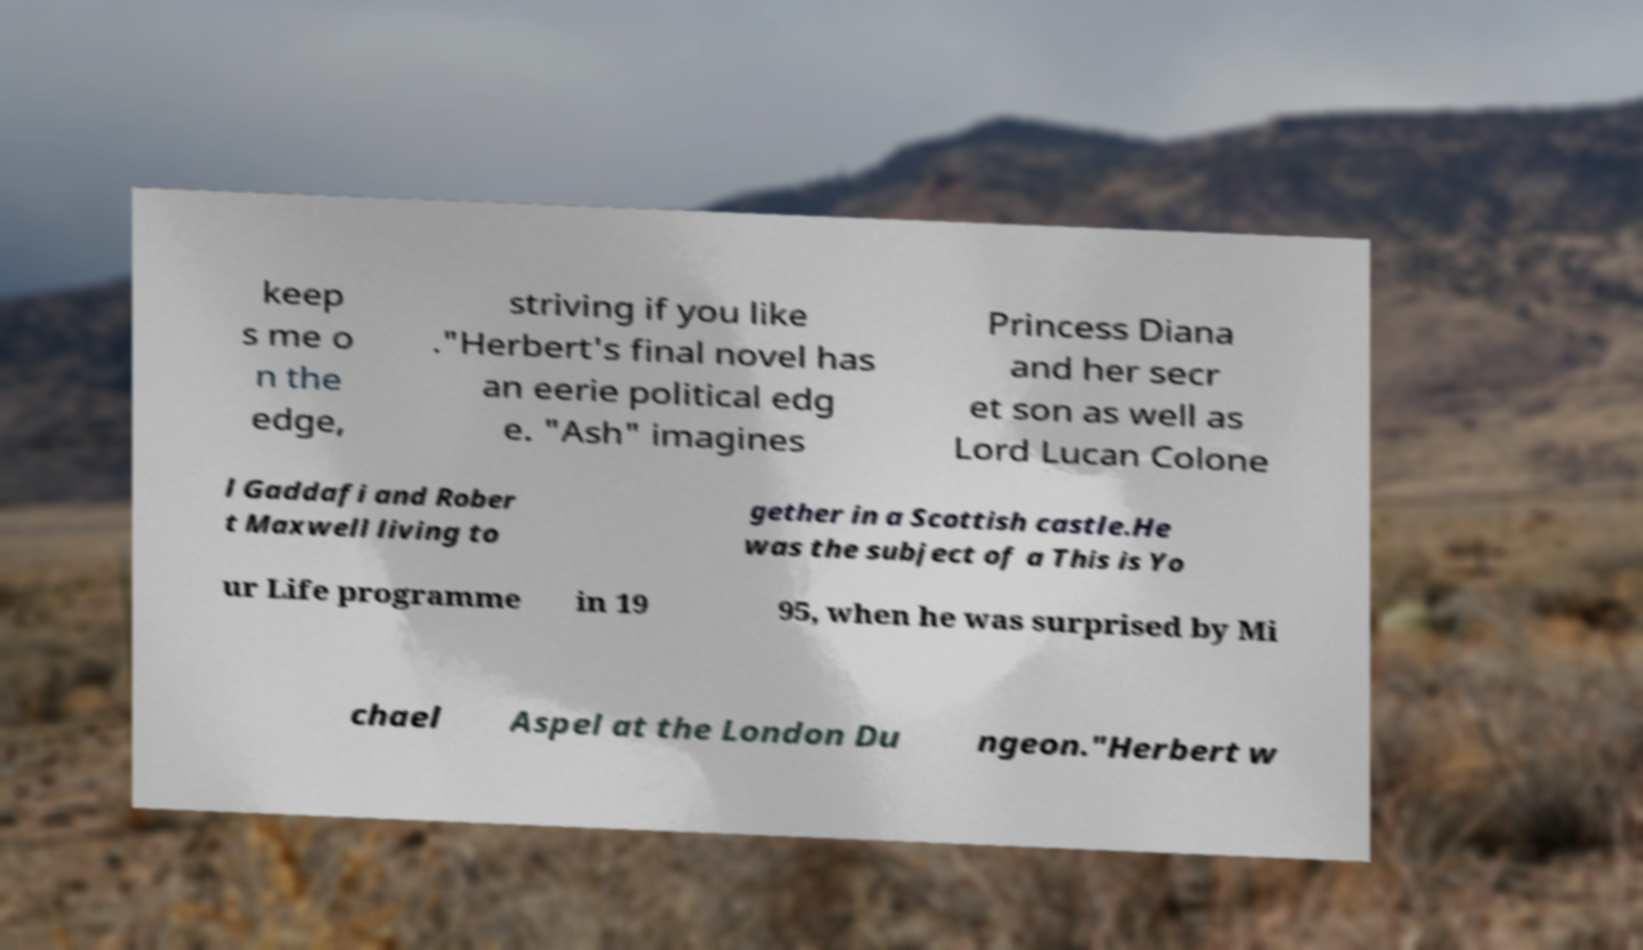For documentation purposes, I need the text within this image transcribed. Could you provide that? keep s me o n the edge, striving if you like ."Herbert's final novel has an eerie political edg e. "Ash" imagines Princess Diana and her secr et son as well as Lord Lucan Colone l Gaddafi and Rober t Maxwell living to gether in a Scottish castle.He was the subject of a This is Yo ur Life programme in 19 95, when he was surprised by Mi chael Aspel at the London Du ngeon."Herbert w 